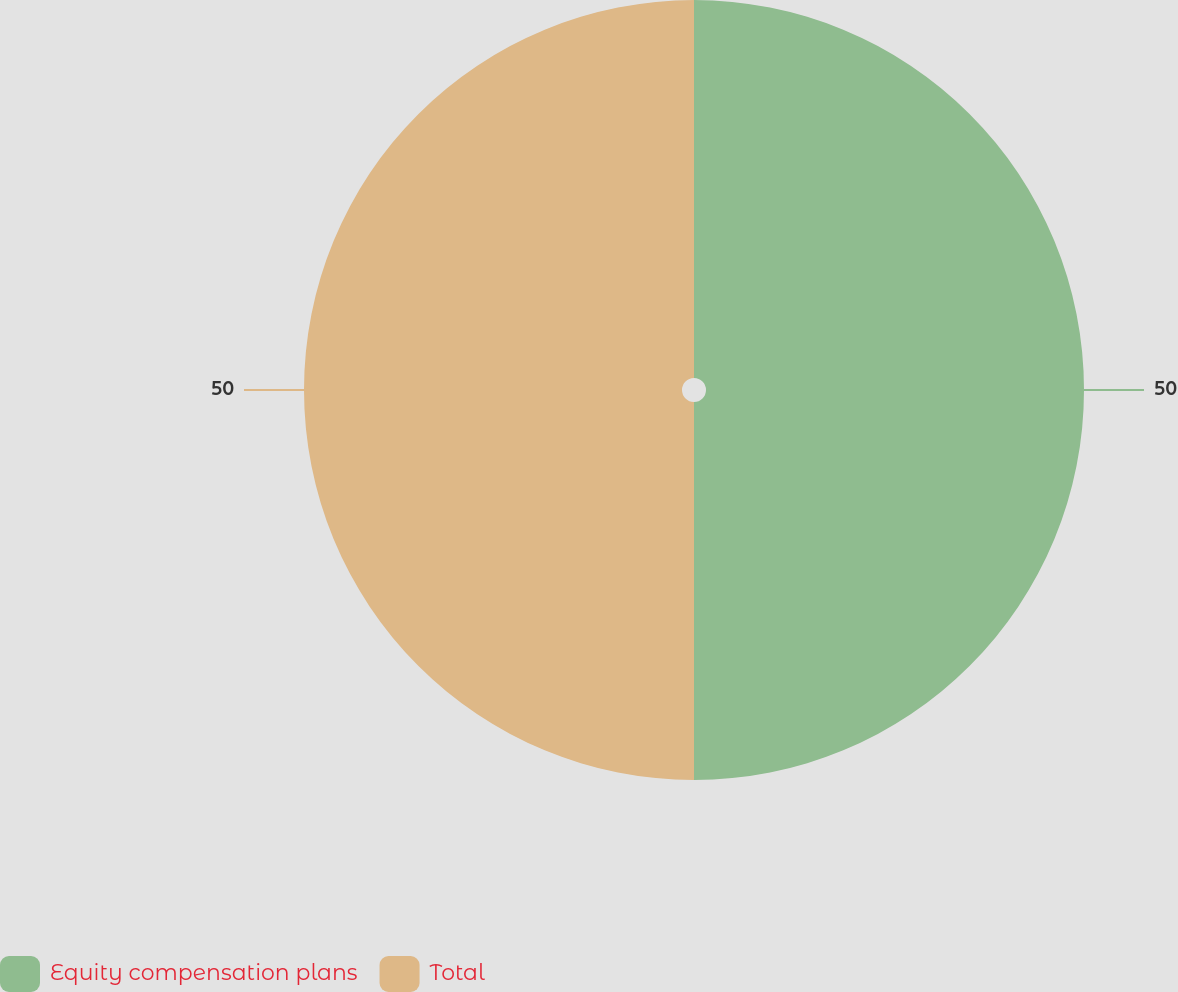<chart> <loc_0><loc_0><loc_500><loc_500><pie_chart><fcel>Equity compensation plans<fcel>Total<nl><fcel>50.0%<fcel>50.0%<nl></chart> 